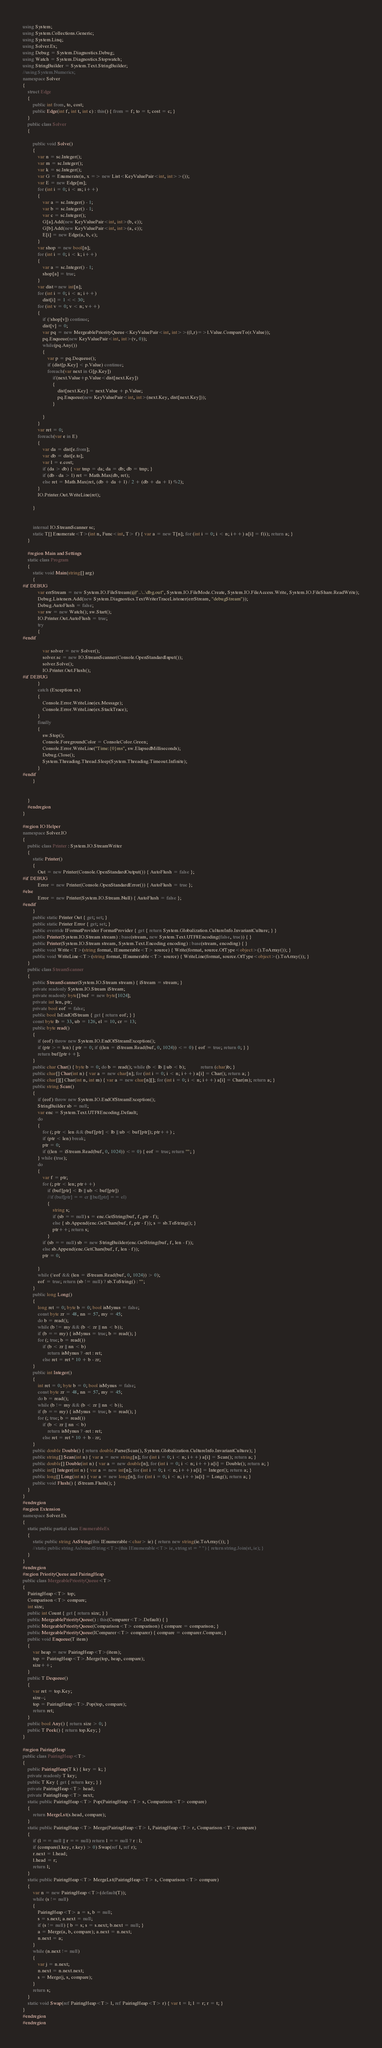<code> <loc_0><loc_0><loc_500><loc_500><_C#_>using System;
using System.Collections.Generic;
using System.Linq;
using Solver.Ex;
using Debug = System.Diagnostics.Debug;
using Watch = System.Diagnostics.Stopwatch;
using StringBuilder = System.Text.StringBuilder;
//using System.Numerics;
namespace Solver
{
    struct Edge
    {
        public int from, to, cost;
        public Edge(int f, int t, int c) : this() { from = f; to = t; cost = c; }
    }
    public class Solver
    {

        public void Solve()
        {
            var n = sc.Integer();
            var m = sc.Integer();
            var k = sc.Integer();
            var G = Enumerate(n, x => new List<KeyValuePair<int, int>>());
            var E = new Edge[m];
            for (int i = 0; i < m; i++)
            {
                var a = sc.Integer() - 1;
                var b = sc.Integer() - 1;
                var c = sc.Integer();
                G[a].Add(new KeyValuePair<int, int>(b, c));
                G[b].Add(new KeyValuePair<int, int>(a, c));
                E[i] = new Edge(a, b, c);
            }
            var shop = new bool[n];
            for (int i = 0; i < k; i++)
            {
                var a = sc.Integer() - 1;
                shop[a] = true;
            }
            var dist=new int[n];
            for (int i = 0; i < n; i++)
                dist[i] = 1 << 30;
            for (int v = 0; v < n; v++)
            {
                if (!shop[v]) continue;
                dist[v] = 0;
                var pq = new MergeablePriorityQueue<KeyValuePair<int, int>>((l,r)=>l.Value.CompareTo(r.Value));
                pq.Enqueue(new KeyValuePair<int, int>(v, 0));
                while(pq.Any())
                {
                    var p = pq.Dequeue();
                    if (dist[p.Key] < p.Value) continue;
                    foreach(var next in G[p.Key])
                        if(next.Value+p.Value<dist[next.Key])
                        {
                            dist[next.Key] = next.Value + p.Value;
                            pq.Enqueue(new KeyValuePair<int, int>(next.Key, dist[next.Key]));
                        }

                }
            }
            var ret = 0;
            foreach(var e in E)
            {
                var da = dist[e.from];
                var db = dist[e.to];
                var l = e.cost;
                if (da > db) { var tmp = da; da = db; db = tmp; }
                if (db - da > l) ret = Math.Max(db, ret);
                else ret = Math.Max(ret, (db + da + l) / 2 + (db + da + l) %2);             
            }
            IO.Printer.Out.WriteLine(ret);
           
        }


        internal IO.StreamScanner sc;
        static T[] Enumerate<T>(int n, Func<int, T> f) { var a = new T[n]; for (int i = 0; i < n; i++) a[i] = f(i); return a; }
    }

    #region Main and Settings
    static class Program
    {
        static void Main(string[] arg)
        {
#if DEBUG
            var errStream = new System.IO.FileStream(@"..\..\dbg.out", System.IO.FileMode.Create, System.IO.FileAccess.Write, System.IO.FileShare.ReadWrite);
            Debug.Listeners.Add(new System.Diagnostics.TextWriterTraceListener(errStream, "debugStream"));
            Debug.AutoFlush = false;
            var sw = new Watch(); sw.Start();
            IO.Printer.Out.AutoFlush = true;
            try
            {
#endif

                var solver = new Solver();
                solver.sc = new IO.StreamScanner(Console.OpenStandardInput());
                solver.Solve();
                IO.Printer.Out.Flush();
#if DEBUG
            }
            catch (Exception ex)
            {
                Console.Error.WriteLine(ex.Message);
                Console.Error.WriteLine(ex.StackTrace);
            }
            finally
            {
                sw.Stop();
                Console.ForegroundColor = ConsoleColor.Green;
                Console.Error.WriteLine("Time:{0}ms", sw.ElapsedMilliseconds);
                Debug.Close();
                System.Threading.Thread.Sleep(System.Threading.Timeout.Infinite);
            }
#endif
        }


    }
    #endregion
}

#region IO Helper
namespace Solver.IO
{
    public class Printer : System.IO.StreamWriter
    {
        static Printer()
        {
            Out = new Printer(Console.OpenStandardOutput()) { AutoFlush = false };
#if DEBUG
            Error = new Printer(Console.OpenStandardError()) { AutoFlush = true };
#else
            Error = new Printer(System.IO.Stream.Null) { AutoFlush = false };
#endif
        }
        public static Printer Out { get; set; }
        public static Printer Error { get; set; }
        public override IFormatProvider FormatProvider { get { return System.Globalization.CultureInfo.InvariantCulture; } }
        public Printer(System.IO.Stream stream) : base(stream, new System.Text.UTF8Encoding(false, true)) { }
        public Printer(System.IO.Stream stream, System.Text.Encoding encoding) : base(stream, encoding) { }
        public void Write<T>(string format, IEnumerable<T> source) { Write(format, source.OfType<object>().ToArray()); }
        public void WriteLine<T>(string format, IEnumerable<T> source) { WriteLine(format, source.OfType<object>().ToArray()); }
    }
    public class StreamScanner
    {
        public StreamScanner(System.IO.Stream stream) { iStream = stream; }
        private readonly System.IO.Stream iStream;
        private readonly byte[] buf = new byte[1024];
        private int len, ptr;
        private bool eof = false;
        public bool IsEndOfStream { get { return eof; } }
        const byte lb = 33, ub = 126, el = 10, cr = 13;
        public byte read()
        {
            if (eof) throw new System.IO.EndOfStreamException();
            if (ptr >= len) { ptr = 0; if ((len = iStream.Read(buf, 0, 1024)) <= 0) { eof = true; return 0; } }
            return buf[ptr++];
        }
        public char Char() { byte b = 0; do b = read(); while (b < lb || ub < b);            return (char)b; }
        public char[] Char(int n) { var a = new char[n]; for (int i = 0; i < n; i++) a[i] = Char(); return a; }
        public char[][] Char(int n, int m) { var a = new char[n][]; for (int i = 0; i < n; i++) a[i] = Char(m); return a; }
        public string Scan()
        {
            if (eof) throw new System.IO.EndOfStreamException();
            StringBuilder sb = null;
            var enc = System.Text.UTF8Encoding.Default;
            do
            {
                for (; ptr < len && (buf[ptr] < lb || ub < buf[ptr]); ptr++) ;
                if (ptr < len) break;
                ptr = 0;
                if ((len = iStream.Read(buf, 0, 1024)) <= 0) { eof = true; return ""; }
            } while (true);
            do
            {
                var f = ptr;
                for (; ptr < len; ptr++)
                    if (buf[ptr] < lb || ub < buf[ptr])
                    //if (buf[ptr] == cr || buf[ptr] == el)
                    {
                        string s;
                        if (sb == null) s = enc.GetString(buf, f, ptr - f);
                        else { sb.Append(enc.GetChars(buf, f, ptr - f)); s = sb.ToString(); }
                        ptr++; return s;
                    }
                if (sb == null) sb = new StringBuilder(enc.GetString(buf, f, len - f));
                else sb.Append(enc.GetChars(buf, f, len - f));
                ptr = 0;

            }
            while (!eof && (len = iStream.Read(buf, 0, 1024)) > 0);
            eof = true; return (sb != null) ? sb.ToString() : "";
        }
        public long Long()
        {
            long ret = 0; byte b = 0; bool isMynus = false;
            const byte zr = 48, nn = 57, my = 45;
            do b = read();
            while (b != my && (b < zr || nn < b));
            if (b == my) { isMynus = true; b = read(); }
            for (; true; b = read())
                if (b < zr || nn < b)
                    return isMynus ? -ret : ret;
                else ret = ret * 10 + b - zr;
        }
        public int Integer()
        {
            int ret = 0; byte b = 0; bool isMynus = false;
            const byte zr = 48, nn = 57, my = 45;
            do b = read();
            while (b != my && (b < zr || nn < b));
            if (b == my) { isMynus = true; b = read(); }
            for (; true; b = read())
                if (b < zr || nn < b)
                    return isMynus ? -ret : ret;
                else ret = ret * 10 + b - zr;
        }
        public double Double() { return double.Parse(Scan(), System.Globalization.CultureInfo.InvariantCulture); }
        public string[] Scan(int n) { var a = new string[n]; for (int i = 0; i < n; i++) a[i] = Scan(); return a; }
        public double[] Double(int n) { var a = new double[n]; for (int i = 0; i < n; i++) a[i] = Double(); return a; }
        public int[] Integer(int n) { var a = new int[n]; for (int i = 0; i < n; i++) a[i] = Integer(); return a; }
        public long[] Long(int n) { var a = new long[n]; for (int i = 0; i < n; i++)a[i] = Long(); return a; }
        public void Flush() { iStream.Flush(); }
    }
}
#endregion
#region Extension
namespace Solver.Ex
{
    static public partial class EnumerableEx
    {
        static public string AsString(this IEnumerable<char> ie) { return new string(ie.ToArray()); }
        //static public string AsJoinedString<T>(this IEnumerable<T> ie, string st = " ") { return string.Join(st, ie); }
    }
}
#endregion
#region PriorityQueue and PairingHeap
public class MergeablePriorityQueue<T>
{
    PairingHeap<T> top;
    Comparison<T> compare;
    int size;
    public int Count { get { return size; } }
    public MergeablePriorityQueue() : this(Comparer<T>.Default) { }
    public MergeablePriorityQueue(Comparison<T> comparison) { compare = comparison; }
    public MergeablePriorityQueue(IComparer<T> comparer) { compare = comparer.Compare; }
    public void Enqueue(T item)
    {
        var heap = new PairingHeap<T>(item);
        top = PairingHeap<T>.Merge(top, heap, compare);
        size++;
    }
    public T Dequeue()
    {
        var ret = top.Key;
        size--;
        top = PairingHeap<T>.Pop(top, compare);
        return ret;
    }
    public bool Any() { return size > 0; }
    public T Peek() { return top.Key; }
}

#region PairingHeap
public class PairingHeap<T>
{
    public PairingHeap(T k) { key = k; }
    private readonly T key;
    public T Key { get { return key; } }
    private PairingHeap<T> head;
    private PairingHeap<T> next;
    static public PairingHeap<T> Pop(PairingHeap<T> s, Comparison<T> compare)
    {
        return MergeLst(s.head, compare);
    }
    static public PairingHeap<T> Merge(PairingHeap<T> l, PairingHeap<T> r, Comparison<T> compare)
    {
        if (l == null || r == null) return l == null ? r : l;
        if (compare(l.key, r.key) > 0) Swap(ref l, ref r);
        r.next = l.head;
        l.head = r;
        return l;
    }
    static public PairingHeap<T> MergeLst(PairingHeap<T> s, Comparison<T> compare)
    {
        var n = new PairingHeap<T>(default(T));
        while (s != null)
        {
            PairingHeap<T> a = s, b = null;
            s = s.next; a.next = null;
            if (s != null) { b = s; s = s.next; b.next = null; }
            a = Merge(a, b, compare); a.next = n.next;
            n.next = a;
        }
        while (n.next != null)
        {
            var j = n.next;
            n.next = n.next.next;
            s = Merge(j, s, compare);
        }
        return s;
    }
    static void Swap(ref PairingHeap<T> l, ref PairingHeap<T> r) { var t = l; l = r; r = t; }
}
#endregion
#endregion
</code> 